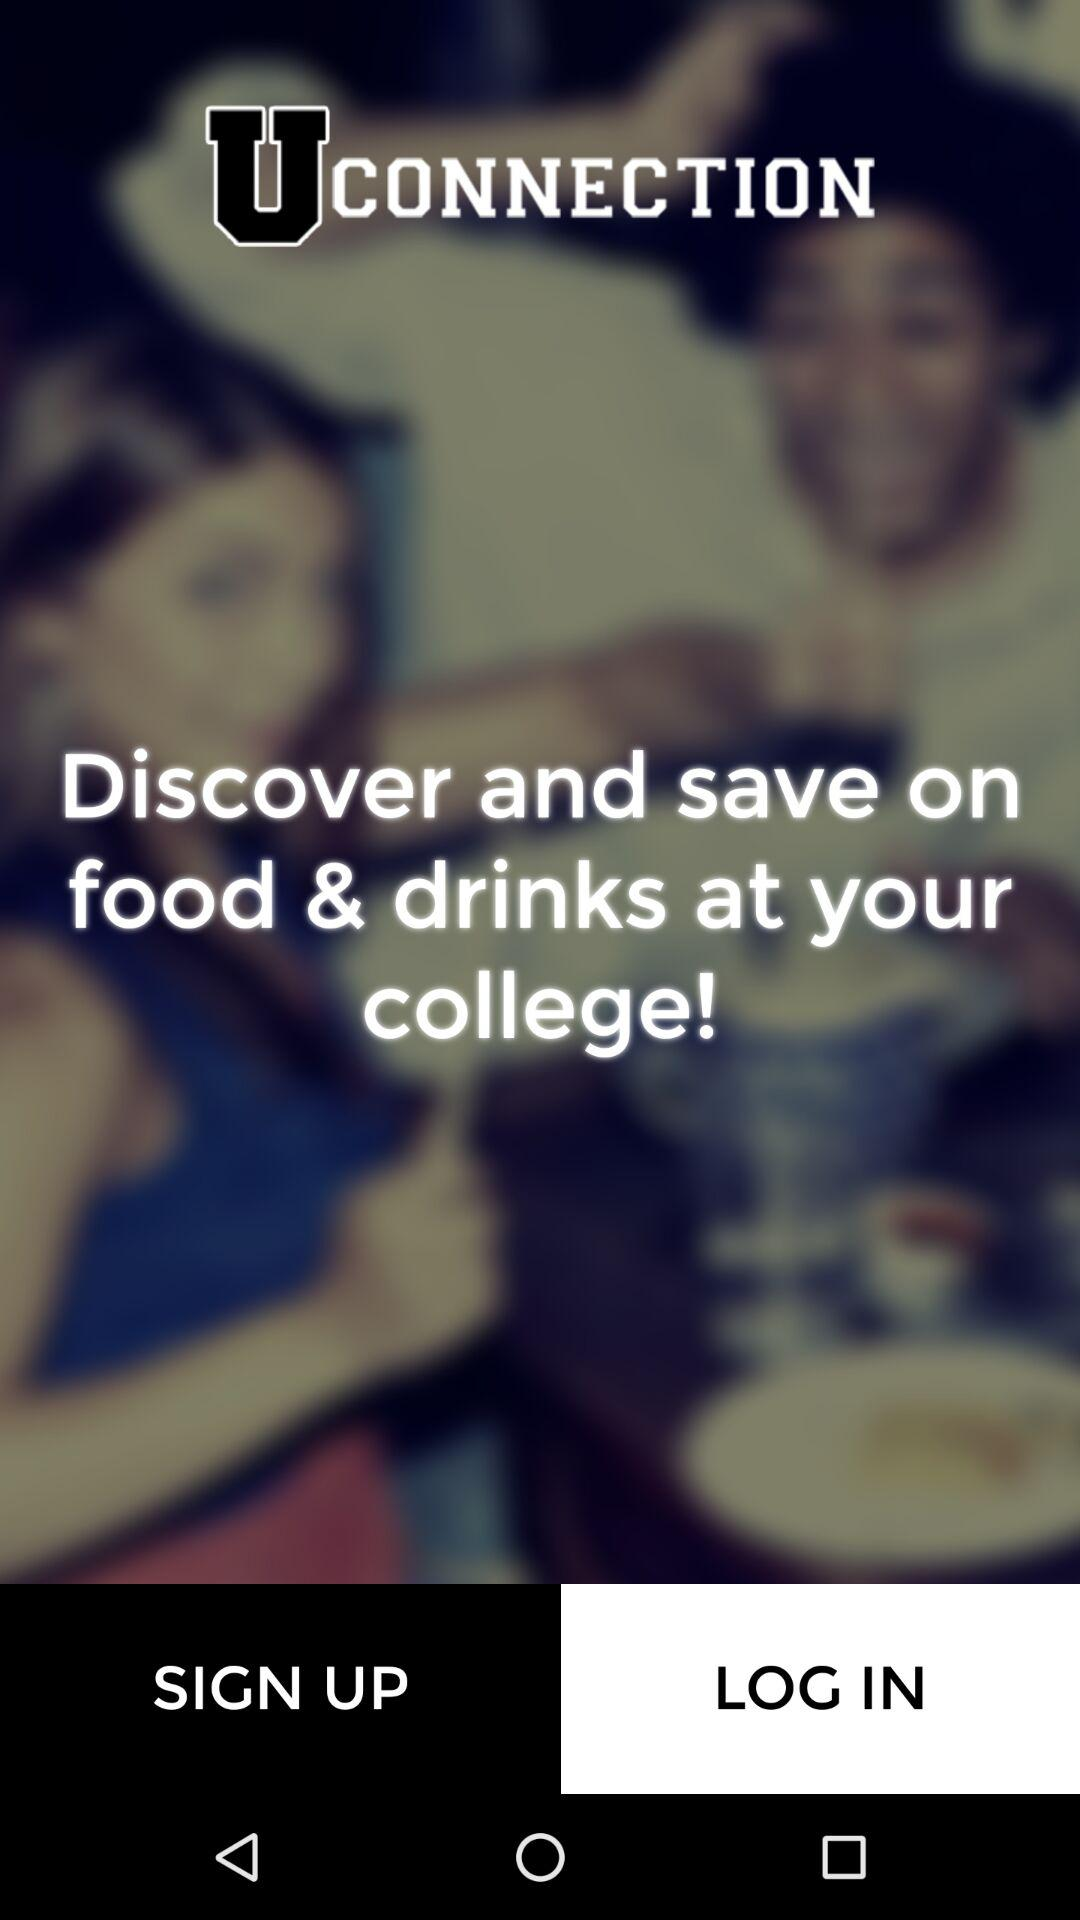What is the application name? The application name is "UCONNECTION". 